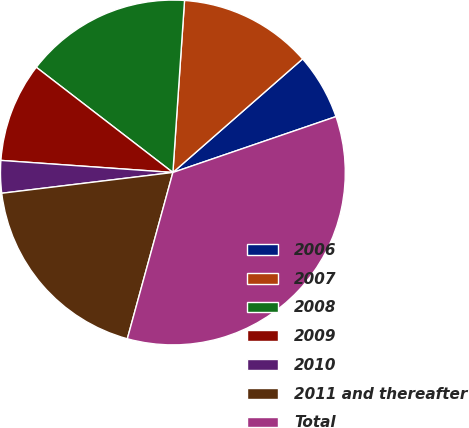Convert chart to OTSL. <chart><loc_0><loc_0><loc_500><loc_500><pie_chart><fcel>2006<fcel>2007<fcel>2008<fcel>2009<fcel>2010<fcel>2011 and thereafter<fcel>Total<nl><fcel>6.19%<fcel>12.48%<fcel>15.63%<fcel>9.33%<fcel>3.04%<fcel>18.82%<fcel>34.51%<nl></chart> 